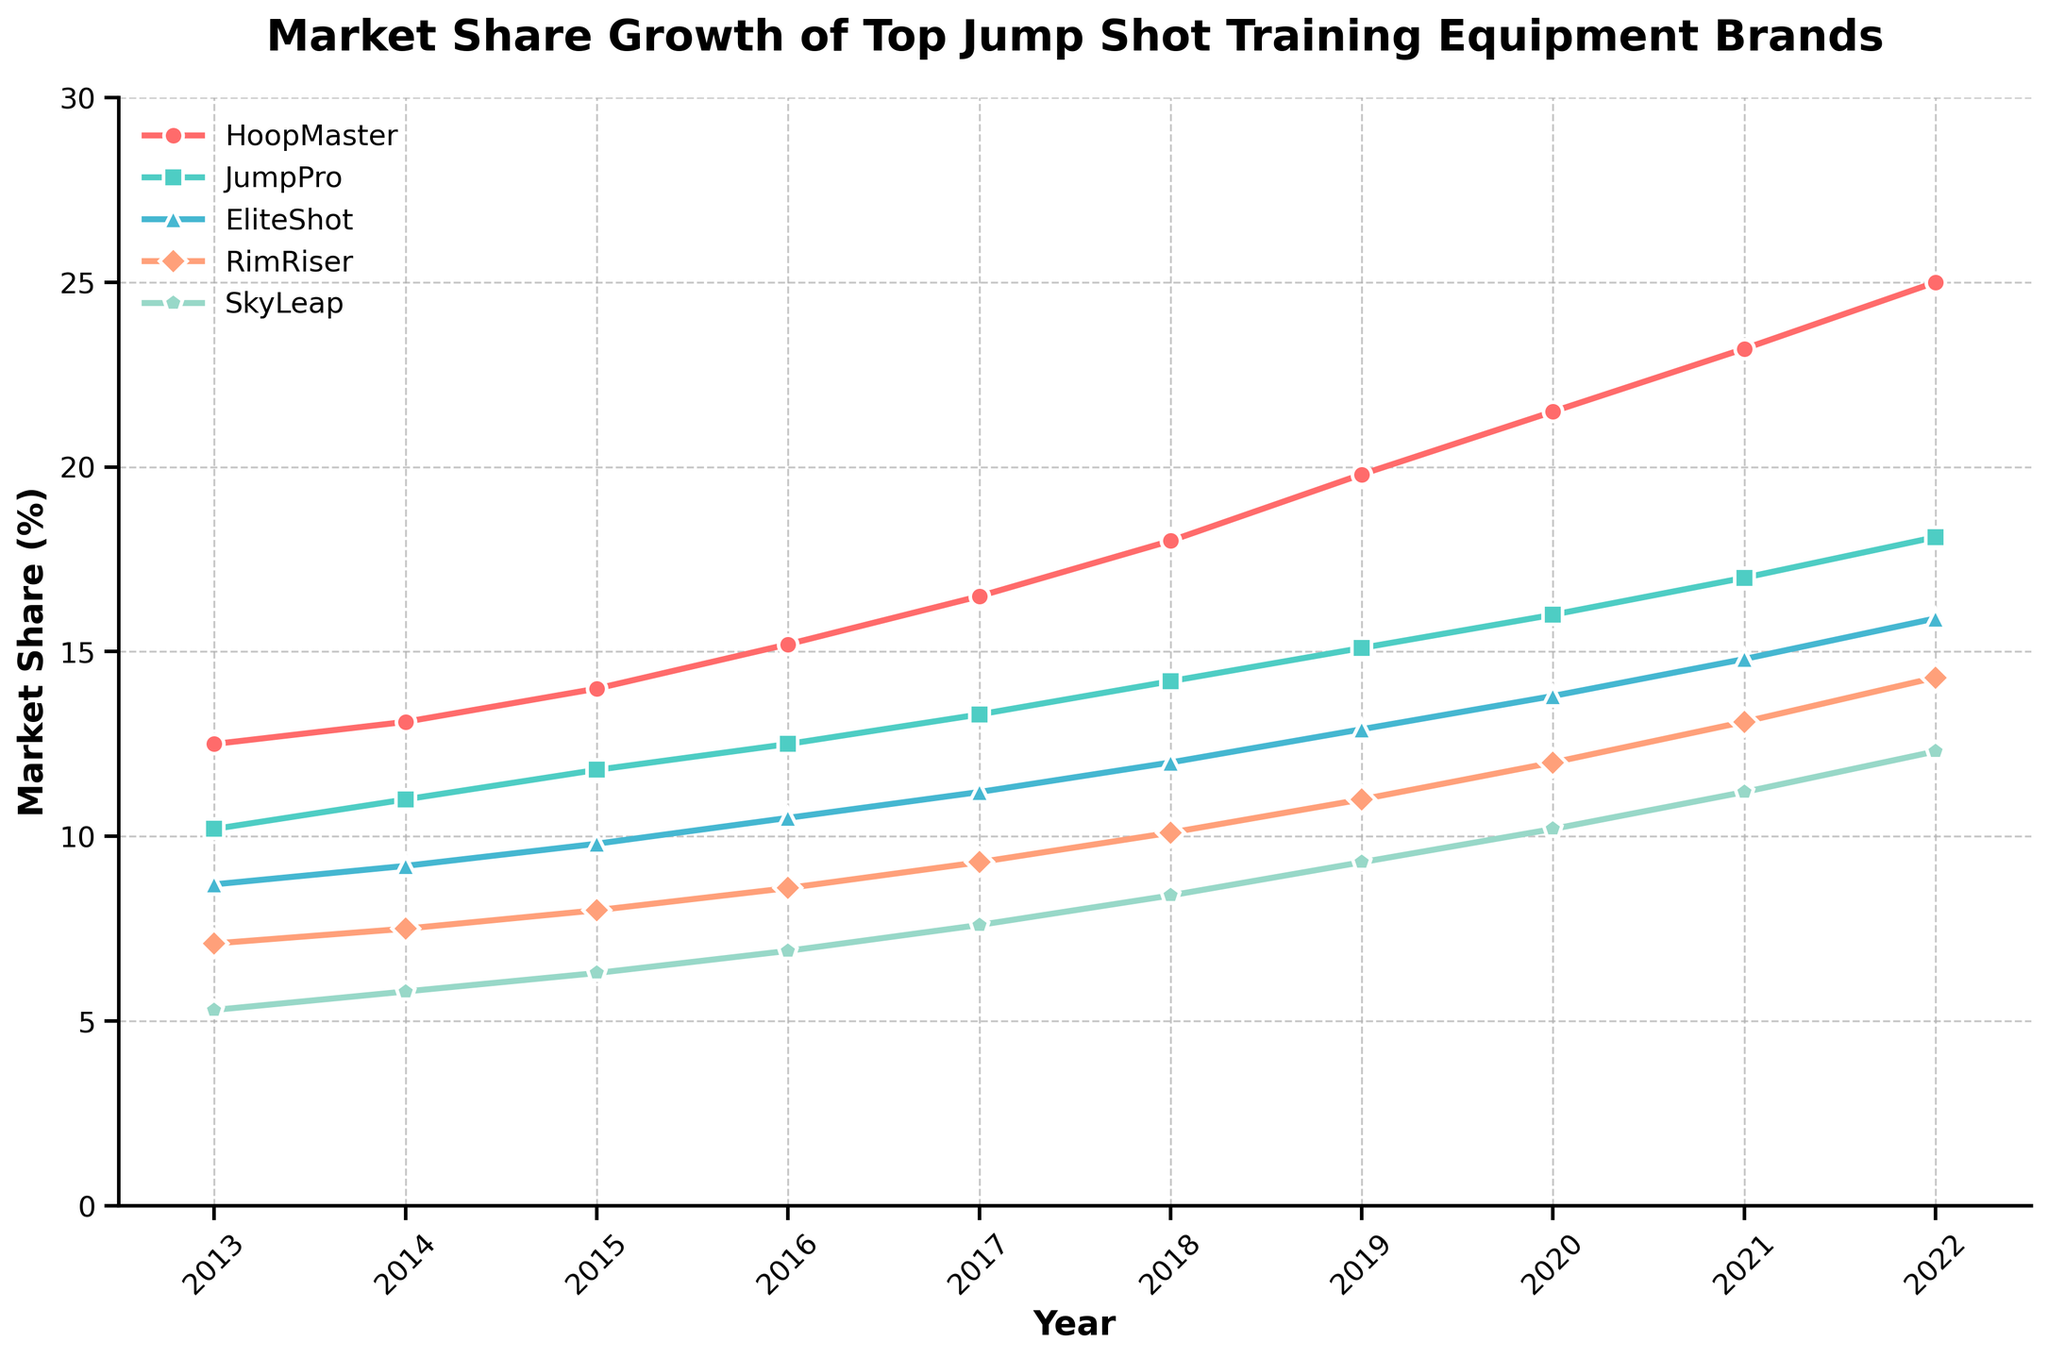Which brand had the highest market share in 2022? Look at the final year (2022) on the x-axis and identify the brand with the highest value on the y-axis. HoopMaster peaks the highest.
Answer: HoopMaster Which year did JumpPro surpass 15% in market share? Follow the JumpPro line and locate the year where it crosses the 15% y-axis mark. This occurs in 2019.
Answer: 2019 What is the difference in market share between HoopMaster and RimRiser in 2022? Find the values for HoopMaster and RimRiser in 2022, then subtract RimRiser's value from HoopMaster's value (25.0 - 14.3).
Answer: 10.7 Which brand experienced the steepest growth between 2013 and 2018? Observe the change in the slopes of the lines from 2013 to 2018. Calculate the difference in market share for each brand over this period, and determine which has the largest increase.
Answer: HoopMaster In which year did EliteShot have a market share equal to what JumpPro had in 2016? Identify JumpPro's market share in 2016 (12.5). Then, follow EliteShot's line to find the year when it reaches the same market share, which is 2016.
Answer: 2016 Which brand had a consistent increase in market share every year? Check each line to see which one rises every year without any dips. HoopMaster consistently increases each year.
Answer: HoopMaster By what percentage did SkyLeap's market share increase from 2013 to 2022? Calculate the initial and final market share of SkyLeap (5.3 in 2013 and 12.3 in 2022), then find the percentage increase using the formula: ((final - initial) / initial) * 100. ((12.3 - 5.3) / 5.3) * 100 = 132.1%
Answer: 132.1% Which brand had the smallest increase in market share from 2013 to 2014? Compare the increase between 2013 and 2014 for each brand; determine the smallest increase. SkyLeap increased the least, from 5.3 to 5.8, an increase of 0.5.
Answer: SkyLeap In 2017, how many brands had a market share greater than 10%? In 2017, determine the market share for each brand and count those exceeding 10%. There are three brands: HoopMaster (16.5), JumpPro (13.3), and EliteShot (11.2).
Answer: 3 